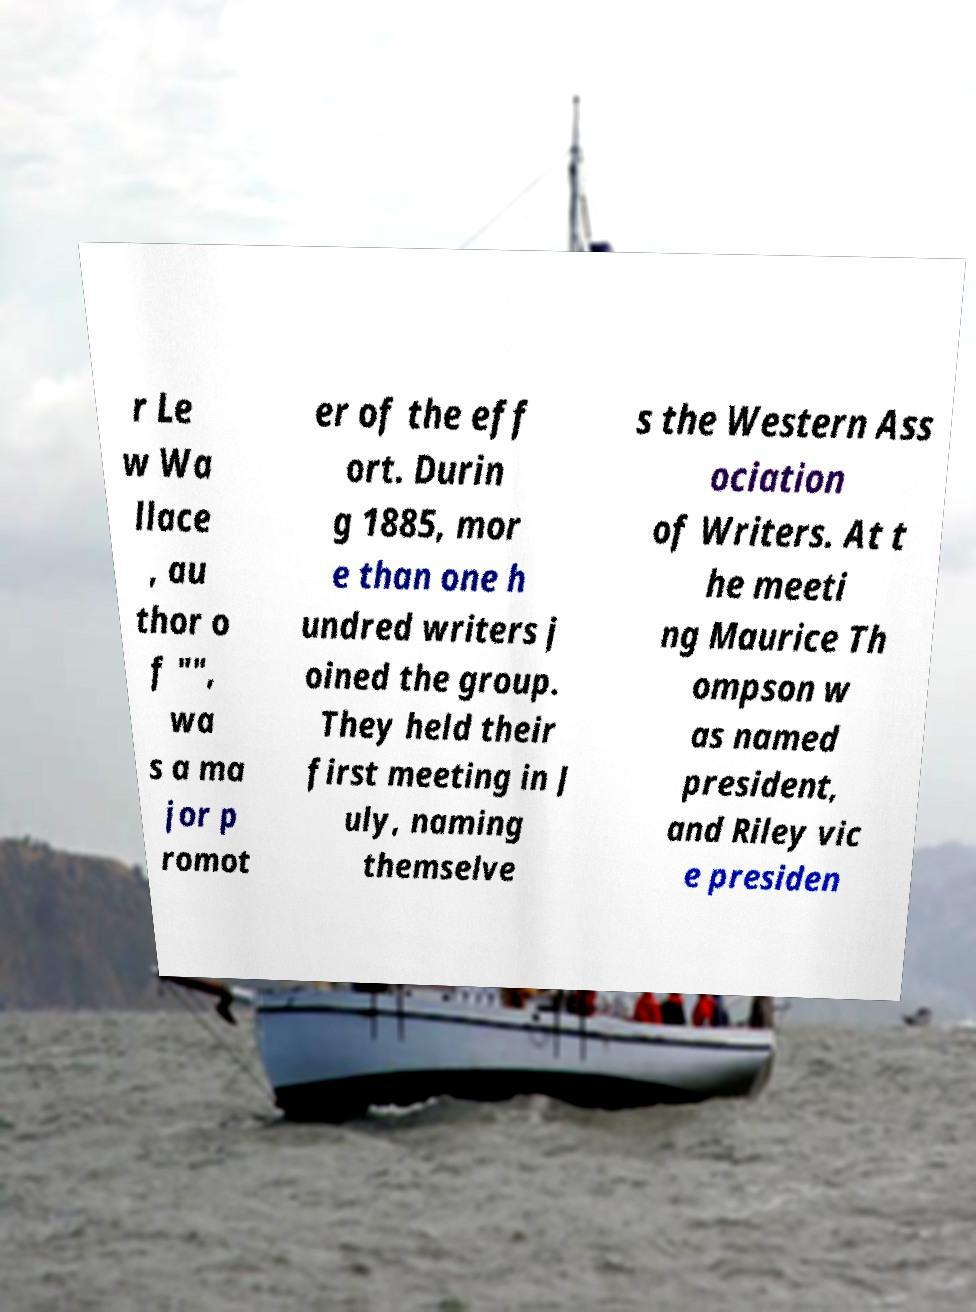Could you extract and type out the text from this image? r Le w Wa llace , au thor o f "", wa s a ma jor p romot er of the eff ort. Durin g 1885, mor e than one h undred writers j oined the group. They held their first meeting in J uly, naming themselve s the Western Ass ociation of Writers. At t he meeti ng Maurice Th ompson w as named president, and Riley vic e presiden 